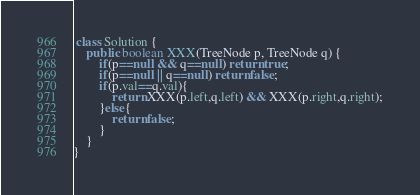<code> <loc_0><loc_0><loc_500><loc_500><_Java_> class Solution {
    public boolean XXX(TreeNode p, TreeNode q) {
        if(p==null && q==null) return true;
        if(p==null || q==null) return false;
        if(p.val==q.val){
            return XXX(p.left,q.left) && XXX(p.right,q.right);
        }else{
            return false;
        }
    }
}

</code> 